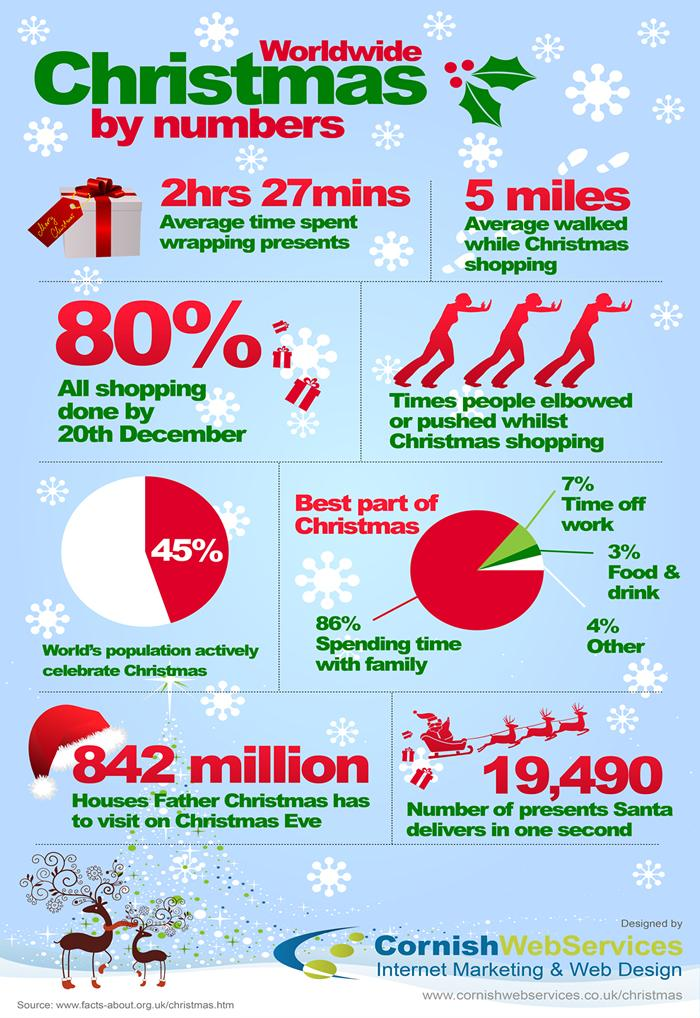Highlight a few significant elements in this photo. According to a recent survey, approximately 55% of the world's population do not celebrate Christmas. During Christmas shopping, a total of three individuals elbowed or pushed others. The majority considers spending time with family as the best part of Christmas. 